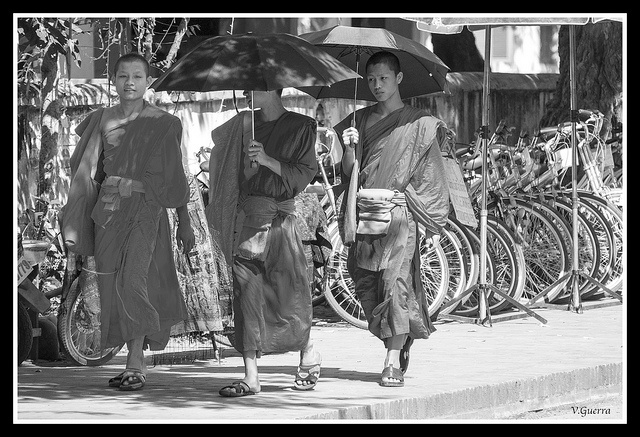Describe the objects in this image and their specific colors. I can see people in black, gray, darkgray, and lightgray tones, people in black, gray, darkgray, and gainsboro tones, people in black, gray, darkgray, and lightgray tones, umbrella in black, gray, darkgray, and lightgray tones, and bicycle in black, lightgray, gray, and darkgray tones in this image. 